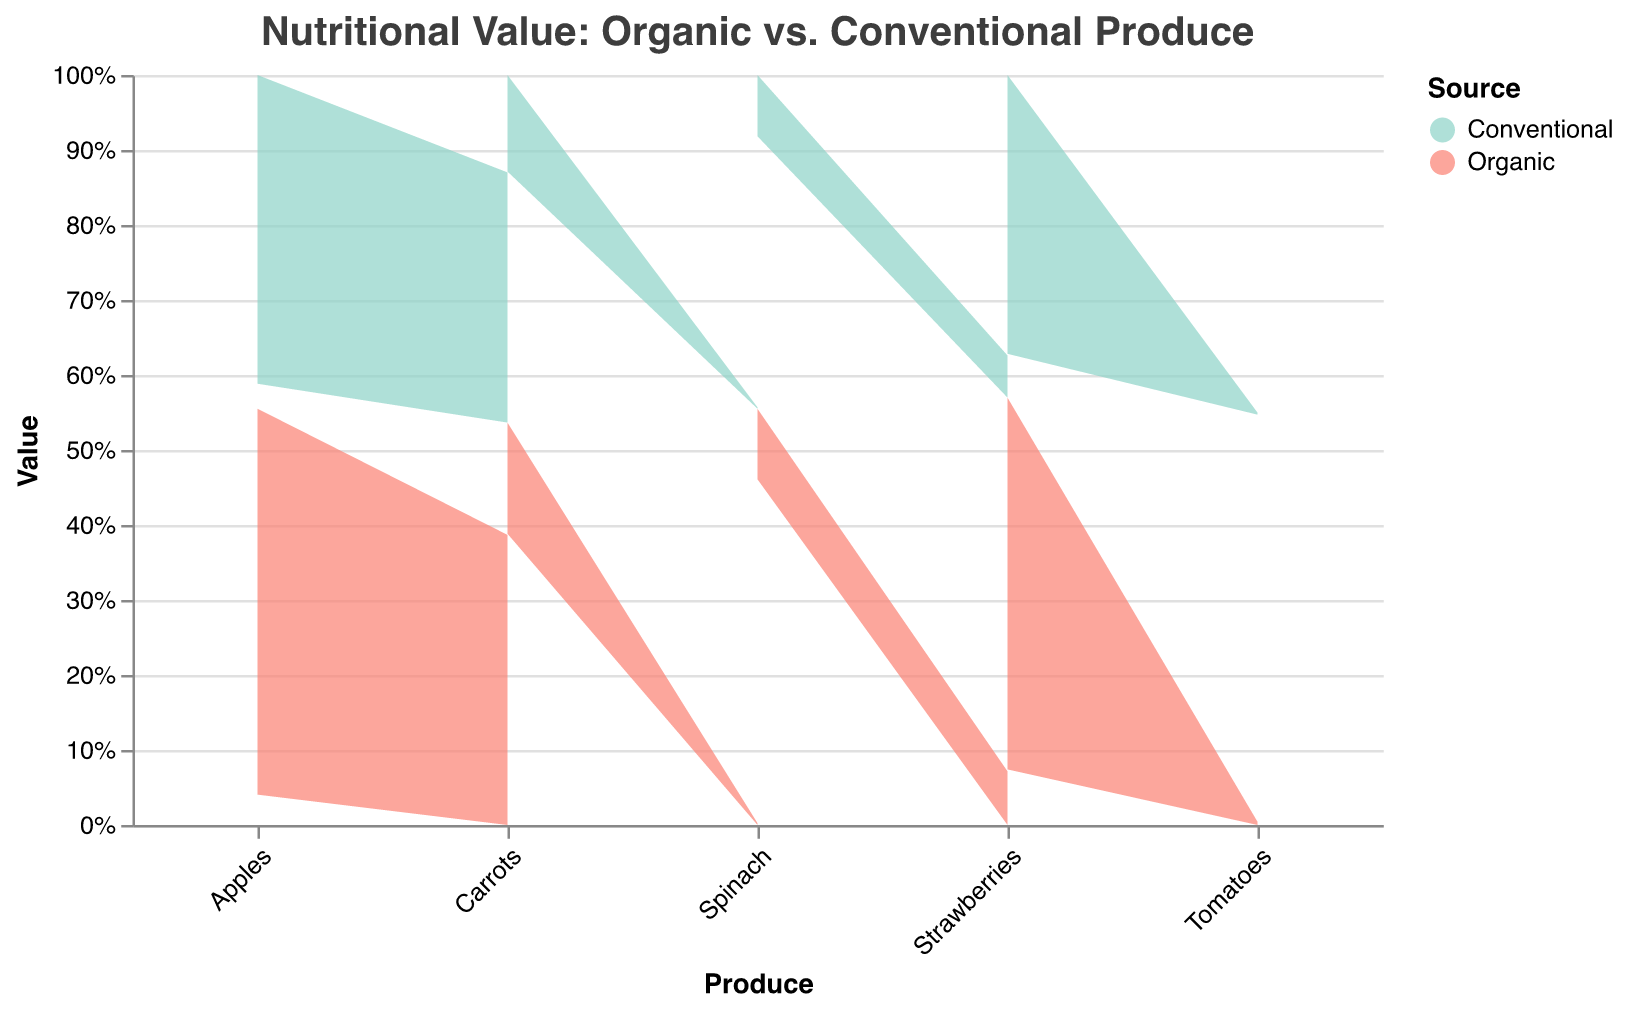What is the title of the chart? The title is shown at the top of the chart. It reads "Nutritional Value: Organic vs. Conventional Produce".
Answer: Nutritional Value: Organic vs. Conventional Produce Which nutrient has the greatest difference in value between organic and conventional apples? The tooltip shows the values for each nutrient. For apples, the difference is largest for Antioxidants (µmol TE) with organic at 150.0 and conventional at 120.0.
Answer: Antioxidants (µmol TE) How much higher is the organic Vitamin C value in strawberries compared to the conventional one? From the tooltip, the organic value is 57.8 mg and the conventional value is 45.4 mg. The difference is calculated as 57.8 - 45.4.
Answer: 12.4 mg Which produce has the highest organic Vitamin K value? By examining the tooltip data for each produce, Spinach has the highest Vitamin K value at 482 µg.
Answer: Spinach Among the leafy greens, which nutrient shows a greater organic value compared to the conventional value? Comparing the three nutrients for spinach: Iron (2.7 vs 2.1), Vitamin K (482 vs 380), Calcium (99 vs 86), Vitamin K shows the greatest difference.
Answer: Vitamin K How does the fiber content in organic tomatoes compare to conventional tomatoes? The tooltip displays the values as 1.2 g for organic and 1.0 g for conventional. Organic tomatoes have slightly more fiber.
Answer: Organic tomatoes have more fiber What is the average Vitamin A (IU) value for organic and conventional tomatoes? The tooltip provides values: Organic (1025 IU) and Conventional (850 IU). The average is (1025 + 850) / 2.
Answer: 937.5 IU Which category, fruits or vegetables, generally shows a higher nutritional difference between organic and conventional produce? Examining each nutrient in each category: Fruits (Apples, Strawberries) vs. Vegetables (Tomatoes, Carrots, Spinach), organic produce consistently shows slightly higher values. A more detailed examination shows that vegetables exhibit bigger individual differences, such as Vitamin K in Spinach and Lycopene in Tomatoes.
Answer: Vegetables In which produce category does the difference in calcium content between organic and conventional show up? Calcium values are displayed for Spinach: Organic (99 mg) and Conventional (86 mg). Spinach, categorized under Leafy Green, shows this difference.
Answer: Leafy Green Which produce has both the highest organic and the highest conventional value for Antioxidants? According to the tooltip: Strawberries have the highest values for both organic (400.0 µmol TE) and conventional (300.0 µmol TE).
Answer: Strawberries 